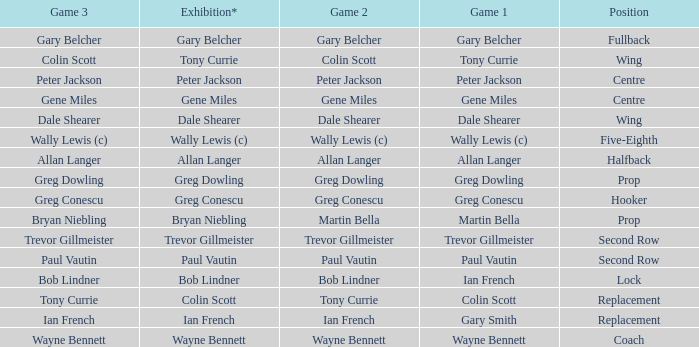What exhibition has greg conescu as game 1? Greg Conescu. Could you parse the entire table as a dict? {'header': ['Game 3', 'Exhibition*', 'Game 2', 'Game 1', 'Position'], 'rows': [['Gary Belcher', 'Gary Belcher', 'Gary Belcher', 'Gary Belcher', 'Fullback'], ['Colin Scott', 'Tony Currie', 'Colin Scott', 'Tony Currie', 'Wing'], ['Peter Jackson', 'Peter Jackson', 'Peter Jackson', 'Peter Jackson', 'Centre'], ['Gene Miles', 'Gene Miles', 'Gene Miles', 'Gene Miles', 'Centre'], ['Dale Shearer', 'Dale Shearer', 'Dale Shearer', 'Dale Shearer', 'Wing'], ['Wally Lewis (c)', 'Wally Lewis (c)', 'Wally Lewis (c)', 'Wally Lewis (c)', 'Five-Eighth'], ['Allan Langer', 'Allan Langer', 'Allan Langer', 'Allan Langer', 'Halfback'], ['Greg Dowling', 'Greg Dowling', 'Greg Dowling', 'Greg Dowling', 'Prop'], ['Greg Conescu', 'Greg Conescu', 'Greg Conescu', 'Greg Conescu', 'Hooker'], ['Bryan Niebling', 'Bryan Niebling', 'Martin Bella', 'Martin Bella', 'Prop'], ['Trevor Gillmeister', 'Trevor Gillmeister', 'Trevor Gillmeister', 'Trevor Gillmeister', 'Second Row'], ['Paul Vautin', 'Paul Vautin', 'Paul Vautin', 'Paul Vautin', 'Second Row'], ['Bob Lindner', 'Bob Lindner', 'Bob Lindner', 'Ian French', 'Lock'], ['Tony Currie', 'Colin Scott', 'Tony Currie', 'Colin Scott', 'Replacement'], ['Ian French', 'Ian French', 'Ian French', 'Gary Smith', 'Replacement'], ['Wayne Bennett', 'Wayne Bennett', 'Wayne Bennett', 'Wayne Bennett', 'Coach']]} 